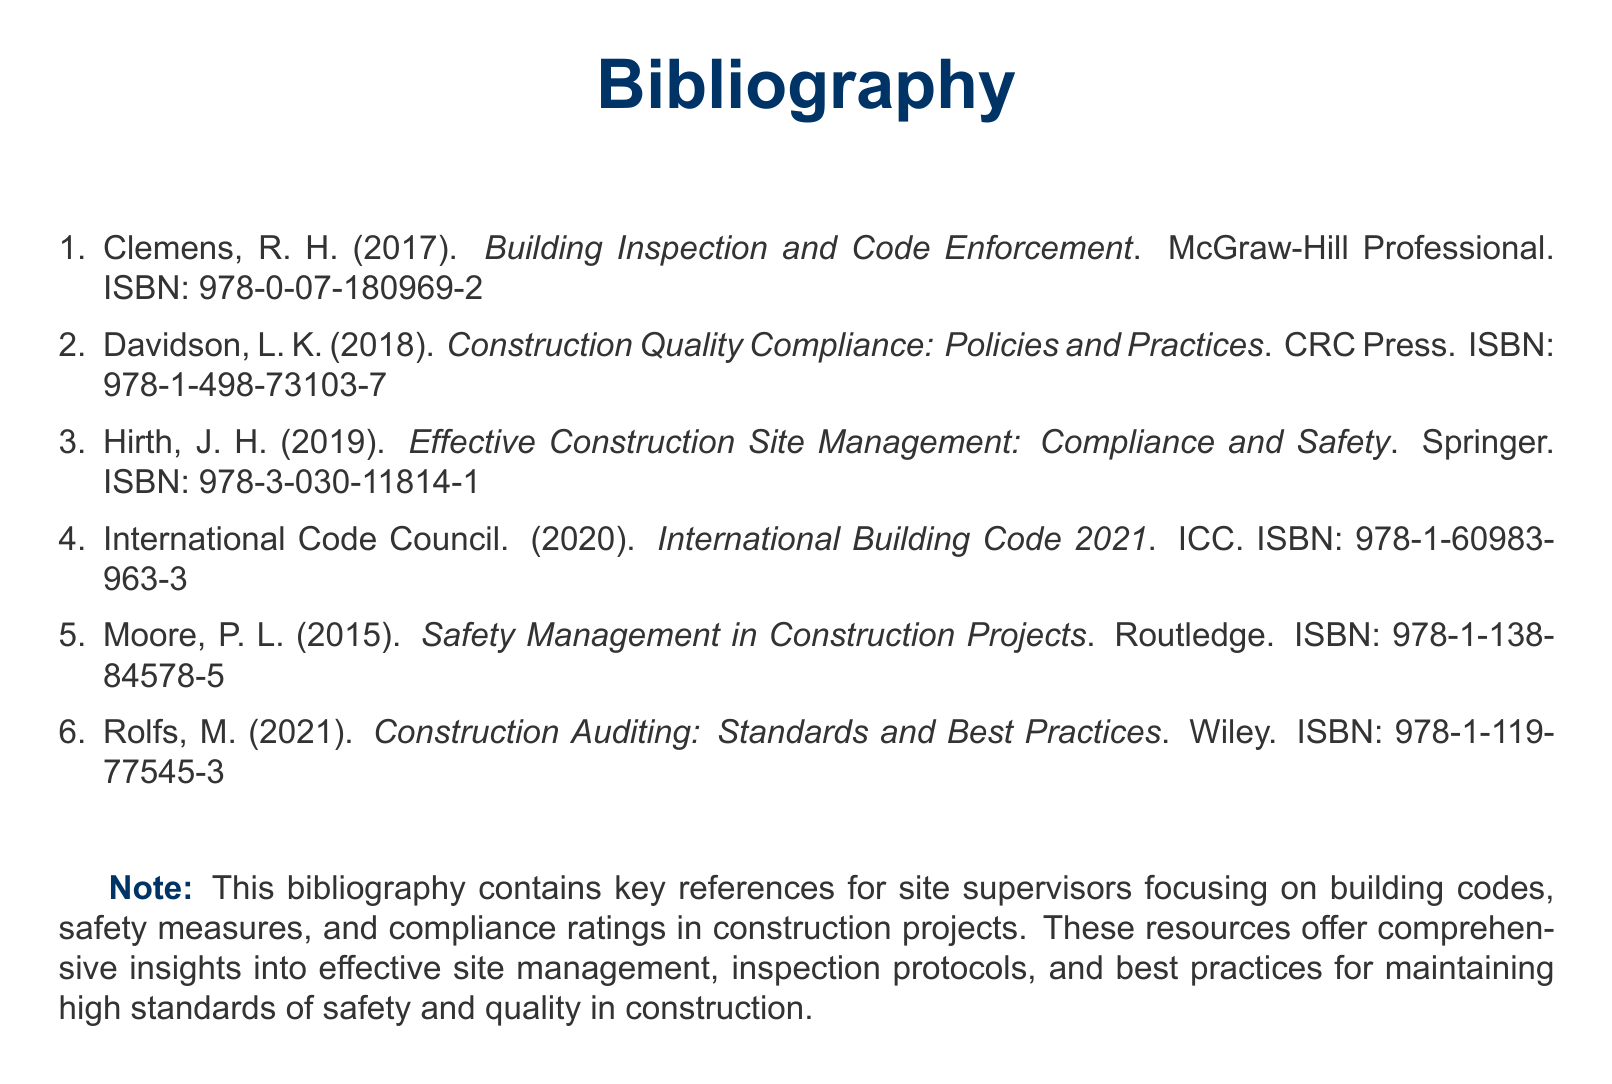What is the title of the first referenced book? The first referenced book is "Building Inspection and Code Enforcement."
Answer: Building Inspection and Code Enforcement Who is the author of the book on safety management? The author of "Safety Management in Construction Projects" is P. L. Moore.
Answer: P. L. Moore In what year was the "International Building Code" published? The "International Building Code 2021" was published in 2020.
Answer: 2020 What ISBN number corresponds to "Construction Auditing: Standards and Best Practices"? The ISBN for "Construction Auditing: Standards and Best Practices" is 978-1-119-77545-3.
Answer: 978-1-119-77545-3 How many references are listed in the bibliography? The document lists a total of 6 references.
Answer: 6 Which publishing house released "Construction Quality Compliance: Policies and Practices"? "Construction Quality Compliance: Policies and Practices" was released by CRC Press.
Answer: CRC Press What is the main focus of the bibliographic references? The references focus on building codes, safety measures, and compliance ratings in construction projects.
Answer: Building codes, safety measures, and compliance ratings Is "Effective Construction Site Management" published by Routledge? No, "Effective Construction Site Management: Compliance and Safety" is published by Springer.
Answer: Springer What is the publication year of the last referenced book? The last referenced book, "Construction Auditing: Standards and Best Practices," was published in 2021.
Answer: 2021 